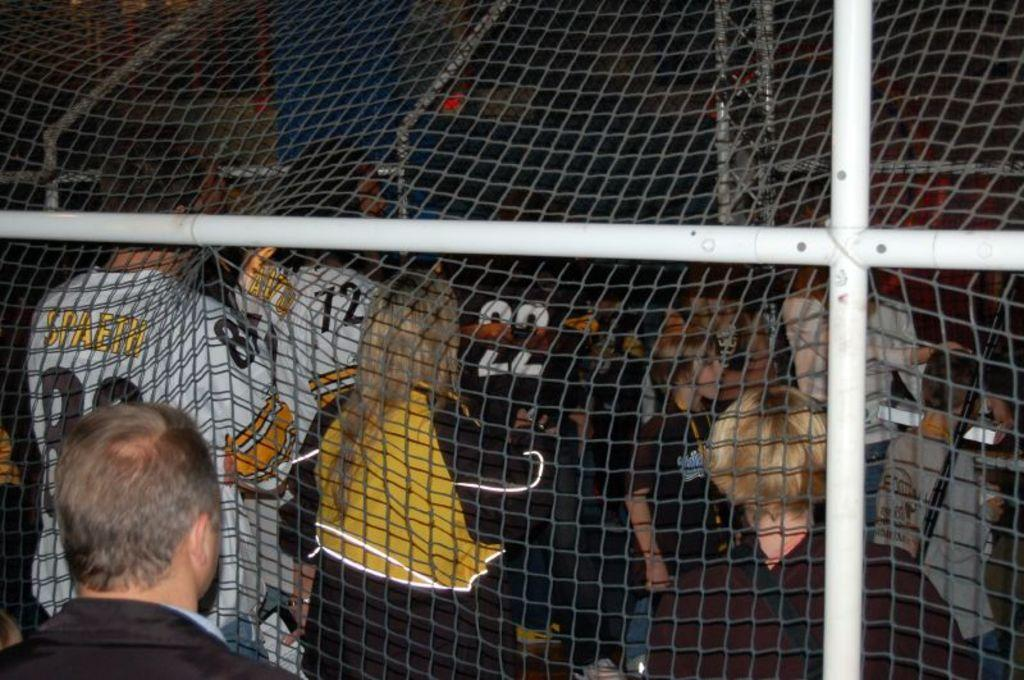What is the main object in the image? There is a net in the image. What are the people in the image doing? The people are standing behind the net. Can you describe the position of the man in the image? There is a man standing in the bottom left of the image. What type of addition problem can be solved using the copper coins in the image? There are no copper coins present in the image, and therefore no addition problem can be solved. 